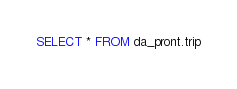<code> <loc_0><loc_0><loc_500><loc_500><_SQL_>SELECT * FROM da_pront.trip
</code> 